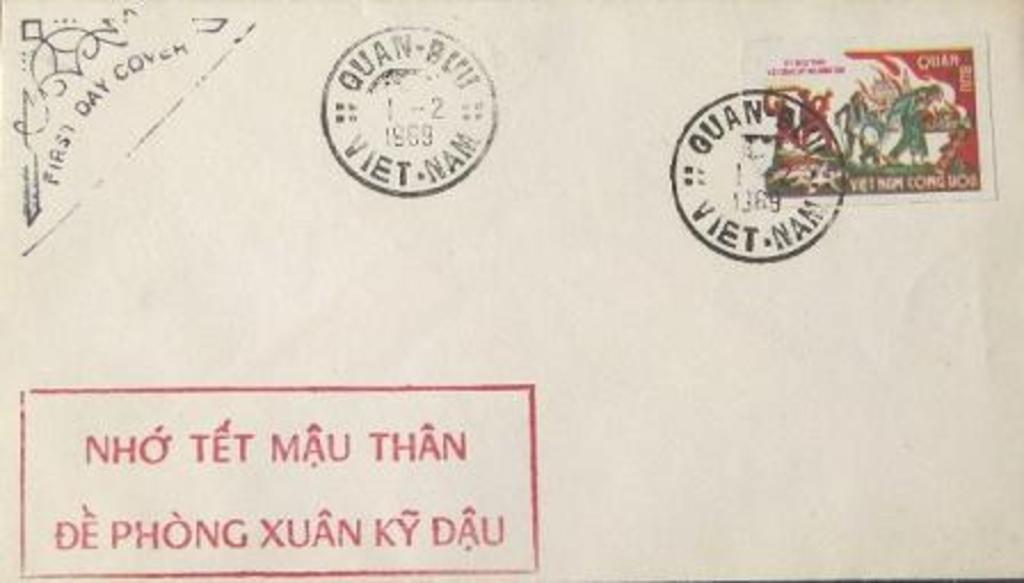<image>
Relay a brief, clear account of the picture shown. Vintage 1969 postage from Viet Nam with a post marked stamp on the stamp. 